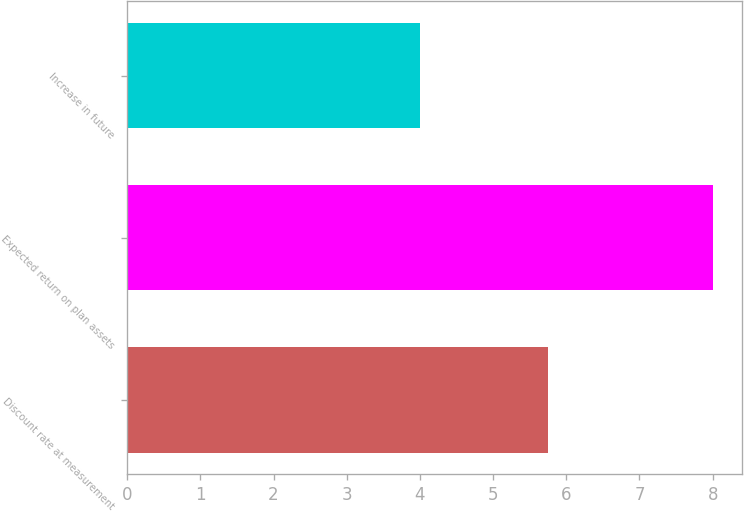Convert chart to OTSL. <chart><loc_0><loc_0><loc_500><loc_500><bar_chart><fcel>Discount rate at measurement<fcel>Expected return on plan assets<fcel>Increase in future<nl><fcel>5.75<fcel>8<fcel>4<nl></chart> 